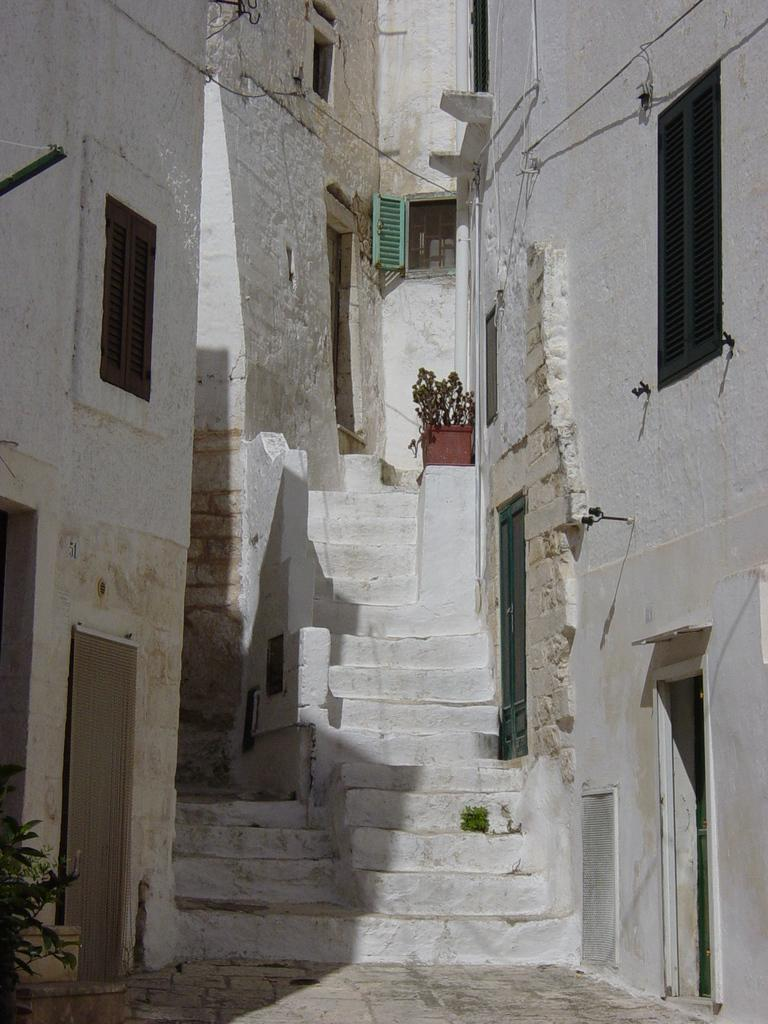What is the main feature of the image? The main feature of the image is the presence of many buildings. Can you describe any specific architectural elements in the image? Yes, there are stairs in front of the middle building. What type of experience does the secretary have in the image? There is no secretary present in the image, so it is not possible to determine their experience. 